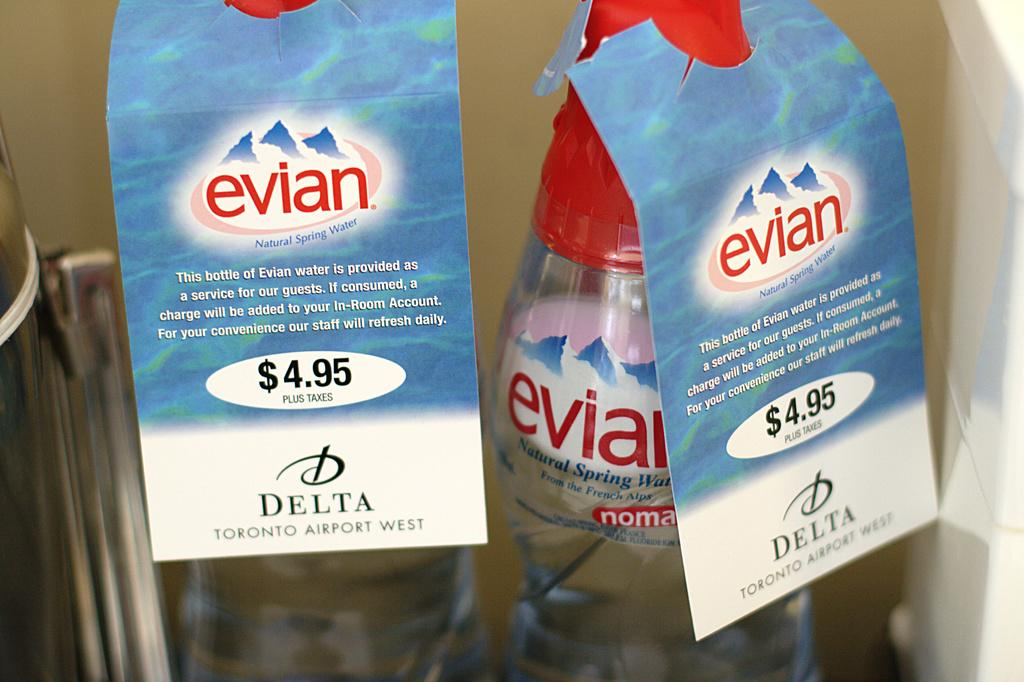What objects can be seen in the image? There are bottles in the image. Are there any additional details about the bottles? Yes, there are price tags on the bottles. What type of line can be seen connecting the bottles in the image? There is no line connecting the bottles in the image. What language is written on the price tags of the bottles? The provided facts do not mention the language written on the price tags. What type of container is used to hold water in the image? There is no container used to hold water present in the image. 